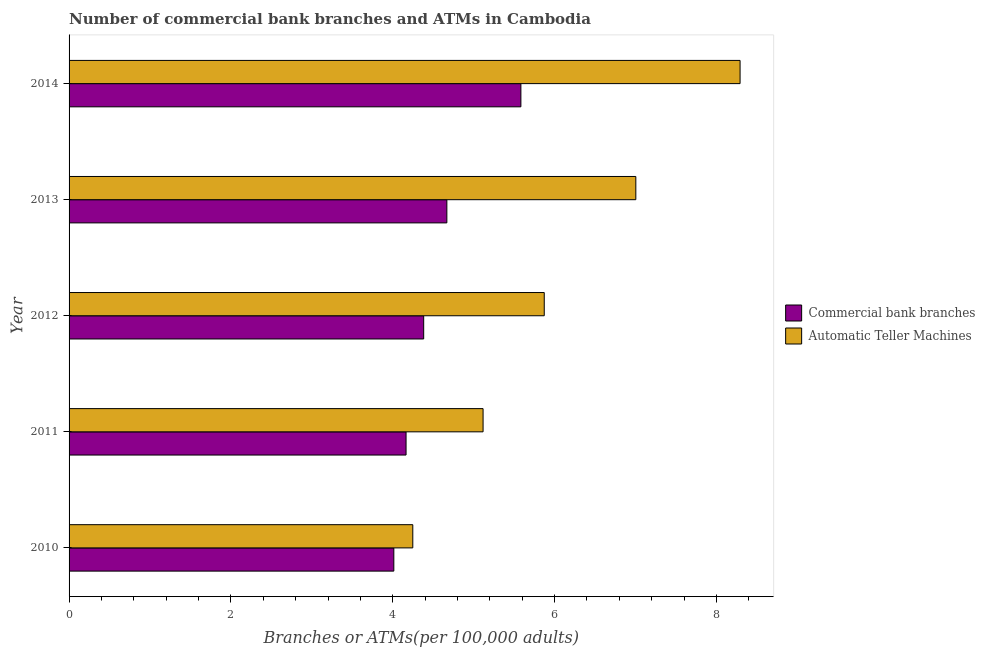How many groups of bars are there?
Ensure brevity in your answer.  5. Are the number of bars per tick equal to the number of legend labels?
Offer a very short reply. Yes. Are the number of bars on each tick of the Y-axis equal?
Provide a succinct answer. Yes. How many bars are there on the 1st tick from the top?
Make the answer very short. 2. What is the number of atms in 2011?
Your answer should be compact. 5.12. Across all years, what is the maximum number of atms?
Keep it short and to the point. 8.29. Across all years, what is the minimum number of atms?
Keep it short and to the point. 4.25. What is the total number of commercal bank branches in the graph?
Make the answer very short. 22.81. What is the difference between the number of atms in 2010 and that in 2012?
Your answer should be compact. -1.62. What is the difference between the number of commercal bank branches in 2010 and the number of atms in 2012?
Provide a succinct answer. -1.86. What is the average number of atms per year?
Offer a very short reply. 6.11. In the year 2013, what is the difference between the number of atms and number of commercal bank branches?
Provide a short and direct response. 2.34. What is the ratio of the number of atms in 2013 to that in 2014?
Your answer should be compact. 0.84. Is the number of commercal bank branches in 2012 less than that in 2013?
Your answer should be very brief. Yes. What is the difference between the highest and the second highest number of commercal bank branches?
Keep it short and to the point. 0.92. What is the difference between the highest and the lowest number of commercal bank branches?
Your response must be concise. 1.57. In how many years, is the number of commercal bank branches greater than the average number of commercal bank branches taken over all years?
Provide a short and direct response. 2. What does the 1st bar from the top in 2011 represents?
Offer a very short reply. Automatic Teller Machines. What does the 1st bar from the bottom in 2012 represents?
Provide a short and direct response. Commercial bank branches. Are all the bars in the graph horizontal?
Provide a succinct answer. Yes. How many years are there in the graph?
Your answer should be very brief. 5. Are the values on the major ticks of X-axis written in scientific E-notation?
Provide a succinct answer. No. Does the graph contain any zero values?
Offer a terse response. No. What is the title of the graph?
Keep it short and to the point. Number of commercial bank branches and ATMs in Cambodia. What is the label or title of the X-axis?
Your response must be concise. Branches or ATMs(per 100,0 adults). What is the label or title of the Y-axis?
Make the answer very short. Year. What is the Branches or ATMs(per 100,000 adults) of Commercial bank branches in 2010?
Your answer should be very brief. 4.01. What is the Branches or ATMs(per 100,000 adults) in Automatic Teller Machines in 2010?
Give a very brief answer. 4.25. What is the Branches or ATMs(per 100,000 adults) in Commercial bank branches in 2011?
Provide a short and direct response. 4.16. What is the Branches or ATMs(per 100,000 adults) of Automatic Teller Machines in 2011?
Your answer should be very brief. 5.12. What is the Branches or ATMs(per 100,000 adults) in Commercial bank branches in 2012?
Provide a short and direct response. 4.38. What is the Branches or ATMs(per 100,000 adults) of Automatic Teller Machines in 2012?
Make the answer very short. 5.87. What is the Branches or ATMs(per 100,000 adults) of Commercial bank branches in 2013?
Make the answer very short. 4.67. What is the Branches or ATMs(per 100,000 adults) of Automatic Teller Machines in 2013?
Ensure brevity in your answer.  7. What is the Branches or ATMs(per 100,000 adults) of Commercial bank branches in 2014?
Your answer should be compact. 5.58. What is the Branches or ATMs(per 100,000 adults) of Automatic Teller Machines in 2014?
Offer a terse response. 8.29. Across all years, what is the maximum Branches or ATMs(per 100,000 adults) of Commercial bank branches?
Offer a terse response. 5.58. Across all years, what is the maximum Branches or ATMs(per 100,000 adults) of Automatic Teller Machines?
Give a very brief answer. 8.29. Across all years, what is the minimum Branches or ATMs(per 100,000 adults) in Commercial bank branches?
Your response must be concise. 4.01. Across all years, what is the minimum Branches or ATMs(per 100,000 adults) of Automatic Teller Machines?
Provide a succinct answer. 4.25. What is the total Branches or ATMs(per 100,000 adults) in Commercial bank branches in the graph?
Make the answer very short. 22.81. What is the total Branches or ATMs(per 100,000 adults) in Automatic Teller Machines in the graph?
Give a very brief answer. 30.53. What is the difference between the Branches or ATMs(per 100,000 adults) in Commercial bank branches in 2010 and that in 2011?
Make the answer very short. -0.15. What is the difference between the Branches or ATMs(per 100,000 adults) of Automatic Teller Machines in 2010 and that in 2011?
Offer a very short reply. -0.87. What is the difference between the Branches or ATMs(per 100,000 adults) of Commercial bank branches in 2010 and that in 2012?
Your response must be concise. -0.37. What is the difference between the Branches or ATMs(per 100,000 adults) in Automatic Teller Machines in 2010 and that in 2012?
Keep it short and to the point. -1.62. What is the difference between the Branches or ATMs(per 100,000 adults) of Commercial bank branches in 2010 and that in 2013?
Ensure brevity in your answer.  -0.66. What is the difference between the Branches or ATMs(per 100,000 adults) of Automatic Teller Machines in 2010 and that in 2013?
Your answer should be compact. -2.76. What is the difference between the Branches or ATMs(per 100,000 adults) in Commercial bank branches in 2010 and that in 2014?
Your answer should be compact. -1.57. What is the difference between the Branches or ATMs(per 100,000 adults) in Automatic Teller Machines in 2010 and that in 2014?
Keep it short and to the point. -4.04. What is the difference between the Branches or ATMs(per 100,000 adults) of Commercial bank branches in 2011 and that in 2012?
Ensure brevity in your answer.  -0.22. What is the difference between the Branches or ATMs(per 100,000 adults) of Automatic Teller Machines in 2011 and that in 2012?
Provide a succinct answer. -0.76. What is the difference between the Branches or ATMs(per 100,000 adults) in Commercial bank branches in 2011 and that in 2013?
Keep it short and to the point. -0.5. What is the difference between the Branches or ATMs(per 100,000 adults) of Automatic Teller Machines in 2011 and that in 2013?
Give a very brief answer. -1.89. What is the difference between the Branches or ATMs(per 100,000 adults) of Commercial bank branches in 2011 and that in 2014?
Your response must be concise. -1.42. What is the difference between the Branches or ATMs(per 100,000 adults) in Automatic Teller Machines in 2011 and that in 2014?
Provide a succinct answer. -3.18. What is the difference between the Branches or ATMs(per 100,000 adults) in Commercial bank branches in 2012 and that in 2013?
Your response must be concise. -0.29. What is the difference between the Branches or ATMs(per 100,000 adults) of Automatic Teller Machines in 2012 and that in 2013?
Give a very brief answer. -1.13. What is the difference between the Branches or ATMs(per 100,000 adults) in Commercial bank branches in 2012 and that in 2014?
Offer a terse response. -1.2. What is the difference between the Branches or ATMs(per 100,000 adults) of Automatic Teller Machines in 2012 and that in 2014?
Give a very brief answer. -2.42. What is the difference between the Branches or ATMs(per 100,000 adults) of Commercial bank branches in 2013 and that in 2014?
Ensure brevity in your answer.  -0.92. What is the difference between the Branches or ATMs(per 100,000 adults) of Automatic Teller Machines in 2013 and that in 2014?
Ensure brevity in your answer.  -1.29. What is the difference between the Branches or ATMs(per 100,000 adults) in Commercial bank branches in 2010 and the Branches or ATMs(per 100,000 adults) in Automatic Teller Machines in 2011?
Offer a very short reply. -1.1. What is the difference between the Branches or ATMs(per 100,000 adults) in Commercial bank branches in 2010 and the Branches or ATMs(per 100,000 adults) in Automatic Teller Machines in 2012?
Make the answer very short. -1.86. What is the difference between the Branches or ATMs(per 100,000 adults) in Commercial bank branches in 2010 and the Branches or ATMs(per 100,000 adults) in Automatic Teller Machines in 2013?
Provide a short and direct response. -2.99. What is the difference between the Branches or ATMs(per 100,000 adults) in Commercial bank branches in 2010 and the Branches or ATMs(per 100,000 adults) in Automatic Teller Machines in 2014?
Offer a terse response. -4.28. What is the difference between the Branches or ATMs(per 100,000 adults) in Commercial bank branches in 2011 and the Branches or ATMs(per 100,000 adults) in Automatic Teller Machines in 2012?
Give a very brief answer. -1.71. What is the difference between the Branches or ATMs(per 100,000 adults) of Commercial bank branches in 2011 and the Branches or ATMs(per 100,000 adults) of Automatic Teller Machines in 2013?
Your answer should be very brief. -2.84. What is the difference between the Branches or ATMs(per 100,000 adults) of Commercial bank branches in 2011 and the Branches or ATMs(per 100,000 adults) of Automatic Teller Machines in 2014?
Your response must be concise. -4.13. What is the difference between the Branches or ATMs(per 100,000 adults) of Commercial bank branches in 2012 and the Branches or ATMs(per 100,000 adults) of Automatic Teller Machines in 2013?
Provide a succinct answer. -2.62. What is the difference between the Branches or ATMs(per 100,000 adults) in Commercial bank branches in 2012 and the Branches or ATMs(per 100,000 adults) in Automatic Teller Machines in 2014?
Provide a succinct answer. -3.91. What is the difference between the Branches or ATMs(per 100,000 adults) in Commercial bank branches in 2013 and the Branches or ATMs(per 100,000 adults) in Automatic Teller Machines in 2014?
Ensure brevity in your answer.  -3.62. What is the average Branches or ATMs(per 100,000 adults) in Commercial bank branches per year?
Your response must be concise. 4.56. What is the average Branches or ATMs(per 100,000 adults) in Automatic Teller Machines per year?
Provide a succinct answer. 6.11. In the year 2010, what is the difference between the Branches or ATMs(per 100,000 adults) of Commercial bank branches and Branches or ATMs(per 100,000 adults) of Automatic Teller Machines?
Keep it short and to the point. -0.23. In the year 2011, what is the difference between the Branches or ATMs(per 100,000 adults) of Commercial bank branches and Branches or ATMs(per 100,000 adults) of Automatic Teller Machines?
Keep it short and to the point. -0.95. In the year 2012, what is the difference between the Branches or ATMs(per 100,000 adults) in Commercial bank branches and Branches or ATMs(per 100,000 adults) in Automatic Teller Machines?
Your answer should be compact. -1.49. In the year 2013, what is the difference between the Branches or ATMs(per 100,000 adults) in Commercial bank branches and Branches or ATMs(per 100,000 adults) in Automatic Teller Machines?
Offer a very short reply. -2.34. In the year 2014, what is the difference between the Branches or ATMs(per 100,000 adults) in Commercial bank branches and Branches or ATMs(per 100,000 adults) in Automatic Teller Machines?
Offer a very short reply. -2.71. What is the ratio of the Branches or ATMs(per 100,000 adults) of Commercial bank branches in 2010 to that in 2011?
Make the answer very short. 0.96. What is the ratio of the Branches or ATMs(per 100,000 adults) in Automatic Teller Machines in 2010 to that in 2011?
Keep it short and to the point. 0.83. What is the ratio of the Branches or ATMs(per 100,000 adults) of Commercial bank branches in 2010 to that in 2012?
Provide a succinct answer. 0.92. What is the ratio of the Branches or ATMs(per 100,000 adults) of Automatic Teller Machines in 2010 to that in 2012?
Make the answer very short. 0.72. What is the ratio of the Branches or ATMs(per 100,000 adults) of Commercial bank branches in 2010 to that in 2013?
Your answer should be very brief. 0.86. What is the ratio of the Branches or ATMs(per 100,000 adults) of Automatic Teller Machines in 2010 to that in 2013?
Ensure brevity in your answer.  0.61. What is the ratio of the Branches or ATMs(per 100,000 adults) of Commercial bank branches in 2010 to that in 2014?
Your answer should be compact. 0.72. What is the ratio of the Branches or ATMs(per 100,000 adults) of Automatic Teller Machines in 2010 to that in 2014?
Offer a terse response. 0.51. What is the ratio of the Branches or ATMs(per 100,000 adults) in Commercial bank branches in 2011 to that in 2012?
Your answer should be compact. 0.95. What is the ratio of the Branches or ATMs(per 100,000 adults) of Automatic Teller Machines in 2011 to that in 2012?
Offer a terse response. 0.87. What is the ratio of the Branches or ATMs(per 100,000 adults) of Commercial bank branches in 2011 to that in 2013?
Offer a very short reply. 0.89. What is the ratio of the Branches or ATMs(per 100,000 adults) of Automatic Teller Machines in 2011 to that in 2013?
Your response must be concise. 0.73. What is the ratio of the Branches or ATMs(per 100,000 adults) in Commercial bank branches in 2011 to that in 2014?
Keep it short and to the point. 0.75. What is the ratio of the Branches or ATMs(per 100,000 adults) of Automatic Teller Machines in 2011 to that in 2014?
Provide a succinct answer. 0.62. What is the ratio of the Branches or ATMs(per 100,000 adults) of Commercial bank branches in 2012 to that in 2013?
Ensure brevity in your answer.  0.94. What is the ratio of the Branches or ATMs(per 100,000 adults) of Automatic Teller Machines in 2012 to that in 2013?
Ensure brevity in your answer.  0.84. What is the ratio of the Branches or ATMs(per 100,000 adults) of Commercial bank branches in 2012 to that in 2014?
Provide a succinct answer. 0.78. What is the ratio of the Branches or ATMs(per 100,000 adults) of Automatic Teller Machines in 2012 to that in 2014?
Make the answer very short. 0.71. What is the ratio of the Branches or ATMs(per 100,000 adults) of Commercial bank branches in 2013 to that in 2014?
Ensure brevity in your answer.  0.84. What is the ratio of the Branches or ATMs(per 100,000 adults) of Automatic Teller Machines in 2013 to that in 2014?
Ensure brevity in your answer.  0.84. What is the difference between the highest and the second highest Branches or ATMs(per 100,000 adults) of Commercial bank branches?
Keep it short and to the point. 0.92. What is the difference between the highest and the second highest Branches or ATMs(per 100,000 adults) of Automatic Teller Machines?
Ensure brevity in your answer.  1.29. What is the difference between the highest and the lowest Branches or ATMs(per 100,000 adults) in Commercial bank branches?
Provide a short and direct response. 1.57. What is the difference between the highest and the lowest Branches or ATMs(per 100,000 adults) of Automatic Teller Machines?
Your answer should be very brief. 4.04. 